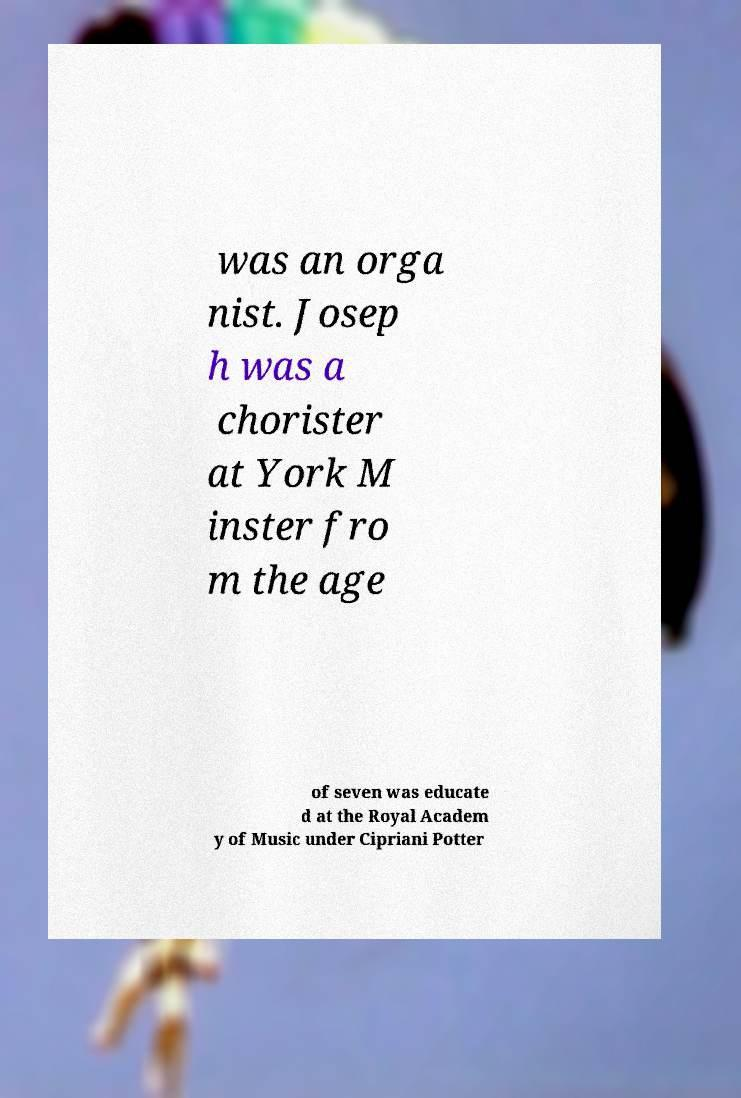Could you extract and type out the text from this image? was an orga nist. Josep h was a chorister at York M inster fro m the age of seven was educate d at the Royal Academ y of Music under Cipriani Potter 